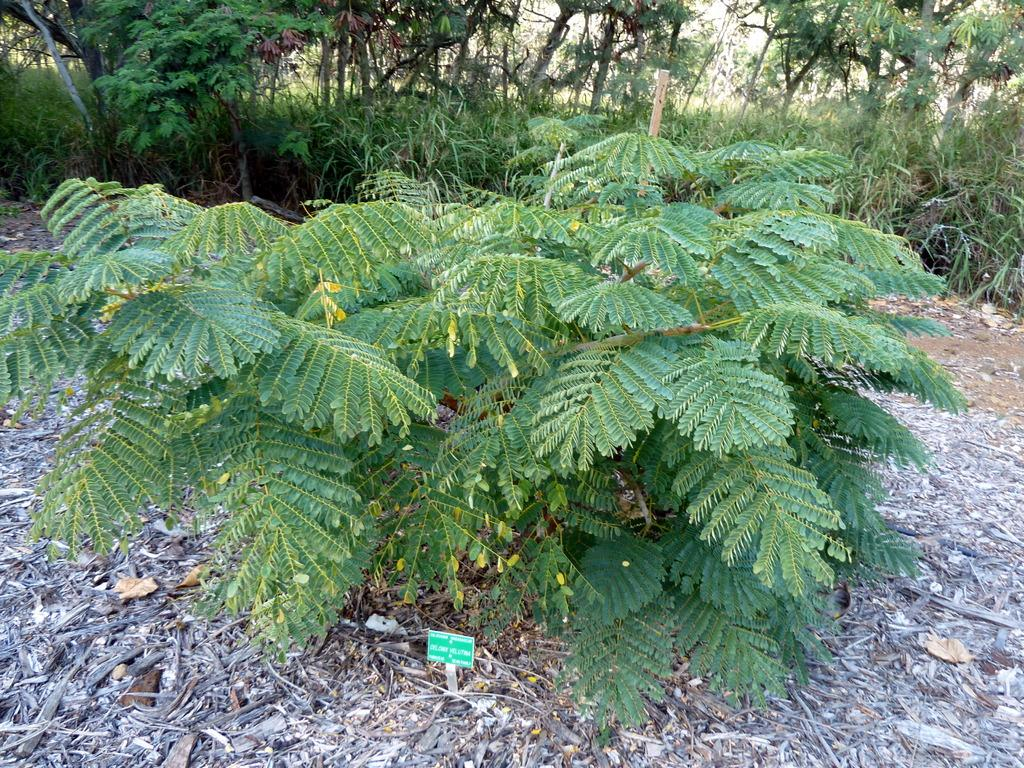What type of vegetation can be seen in the image? There are trees in the image. What is placed in front of one of the trees? There is a board in front of a tree. What is covering the ground beneath the trees? Dried leaves are present on the ground. What type of shoes can be seen hanging from the tree in the image? There are no shoes present in the image; only trees, a board, and dried leaves are visible. 